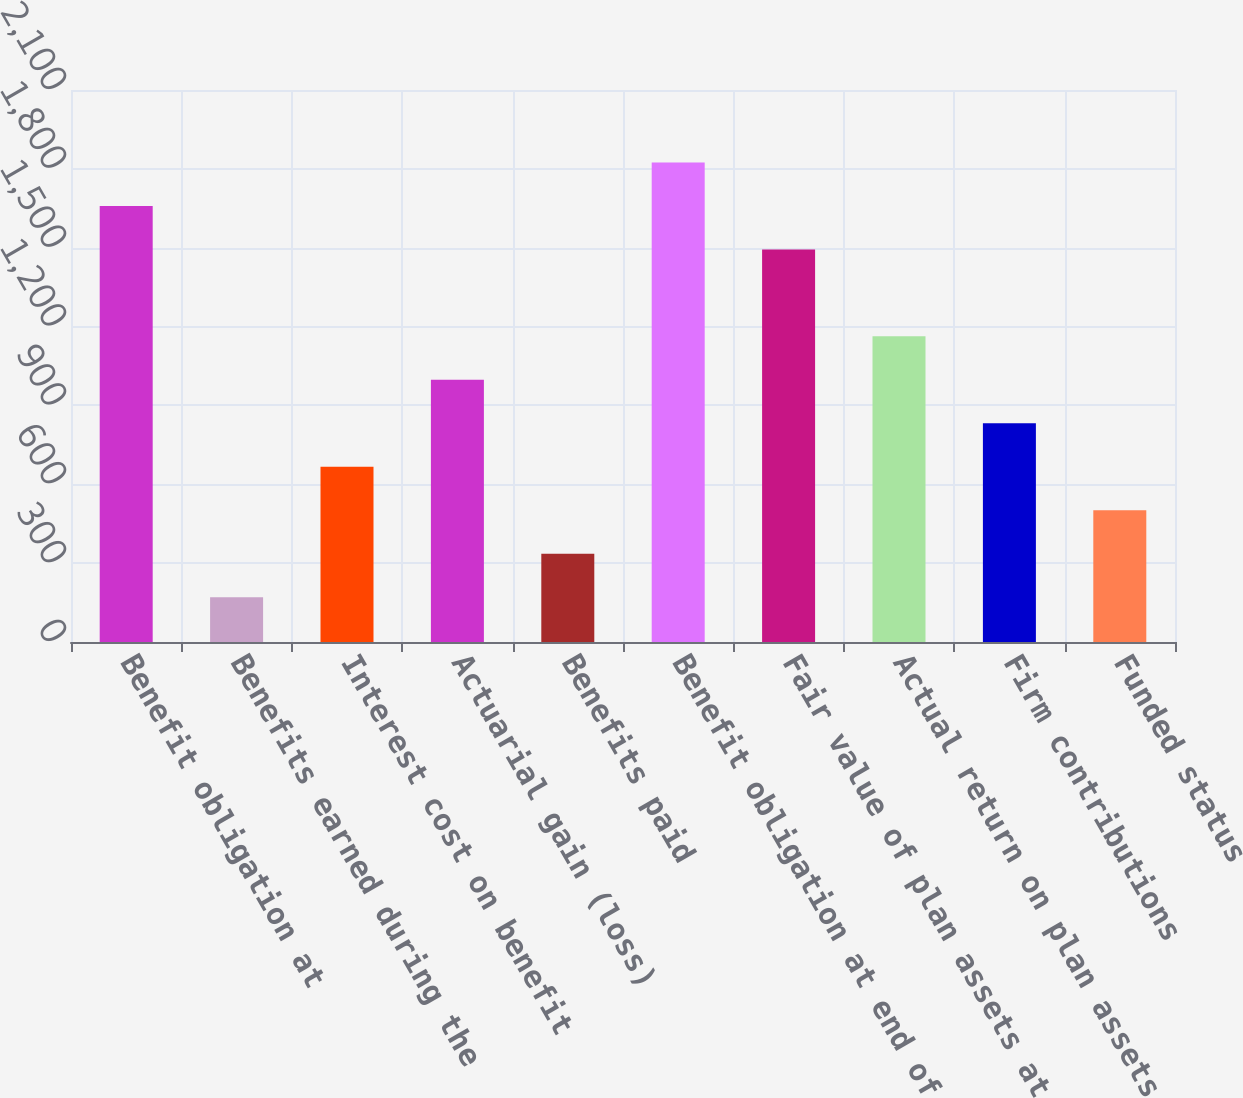<chart> <loc_0><loc_0><loc_500><loc_500><bar_chart><fcel>Benefit obligation at<fcel>Benefits earned during the<fcel>Interest cost on benefit<fcel>Actuarial gain (loss)<fcel>Benefits paid<fcel>Benefit obligation at end of<fcel>Fair value of plan assets at<fcel>Actual return on plan assets<fcel>Firm contributions<fcel>Funded status<nl><fcel>1659<fcel>170.4<fcel>666.6<fcel>997.4<fcel>335.8<fcel>1824.4<fcel>1493.6<fcel>1162.8<fcel>832<fcel>501.2<nl></chart> 